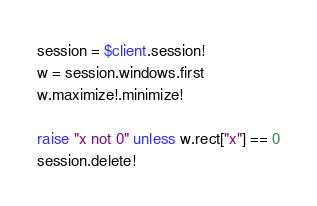Convert code to text. <code><loc_0><loc_0><loc_500><loc_500><_Ruby_>session = $client.session!
w = session.windows.first
w.maximize!.minimize!

raise "x not 0" unless w.rect["x"] == 0
session.delete!
</code> 